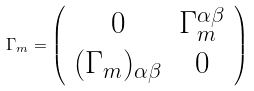<formula> <loc_0><loc_0><loc_500><loc_500>\Gamma _ { m } = \left ( \begin{array} { c c } 0 & \Gamma _ { m } ^ { \alpha \beta } \\ ( \Gamma _ { m } ) _ { \alpha \beta } & 0 \end{array} \right )</formula> 